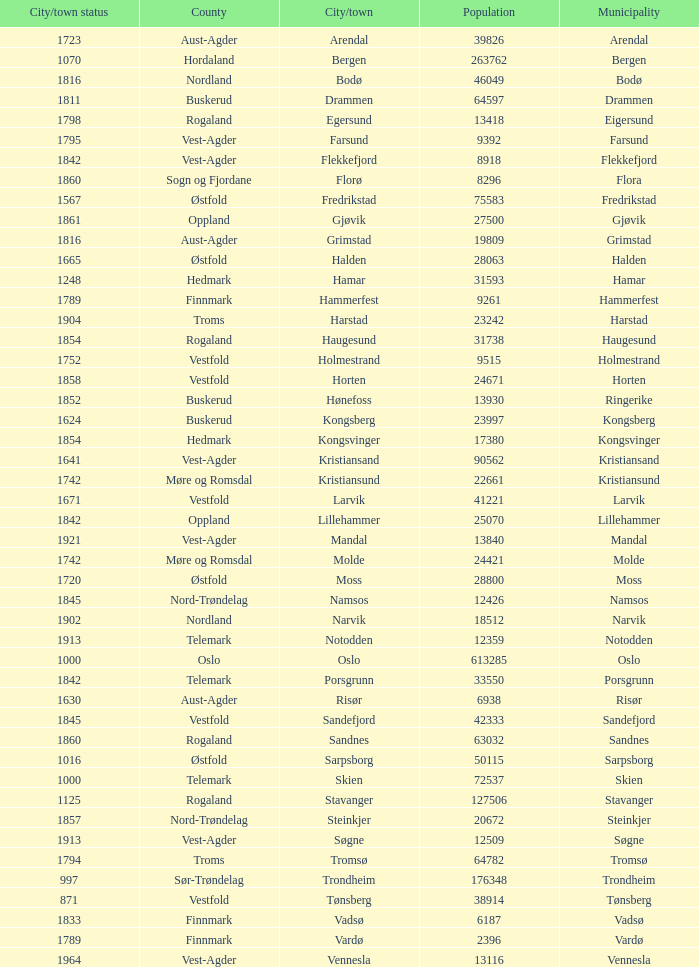What is the total population in the city/town of Arendal? 1.0. 